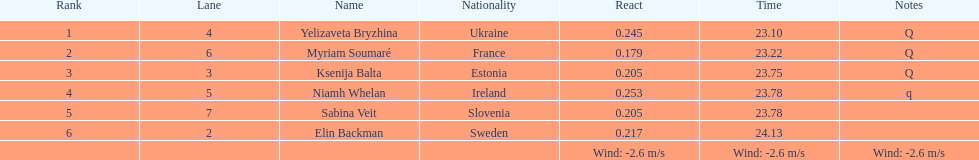What quantity of family names start with "b"? 3. 